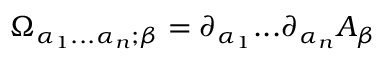Convert formula to latex. <formula><loc_0><loc_0><loc_500><loc_500>\Omega _ { \alpha _ { 1 } \dots \alpha _ { n } ; \beta } = \partial _ { \alpha _ { 1 } } \dots \partial _ { \alpha _ { n } } A _ { \beta }</formula> 